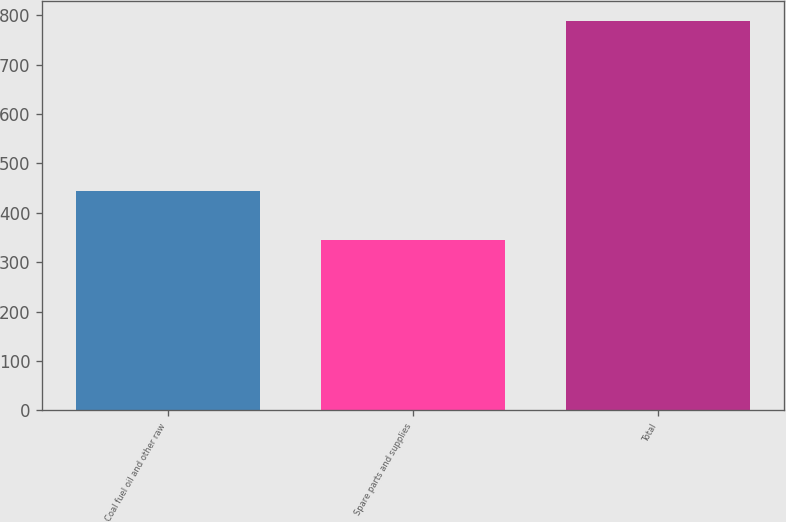Convert chart to OTSL. <chart><loc_0><loc_0><loc_500><loc_500><bar_chart><fcel>Coal fuel oil and other raw<fcel>Spare parts and supplies<fcel>Total<nl><fcel>444<fcel>345<fcel>789<nl></chart> 